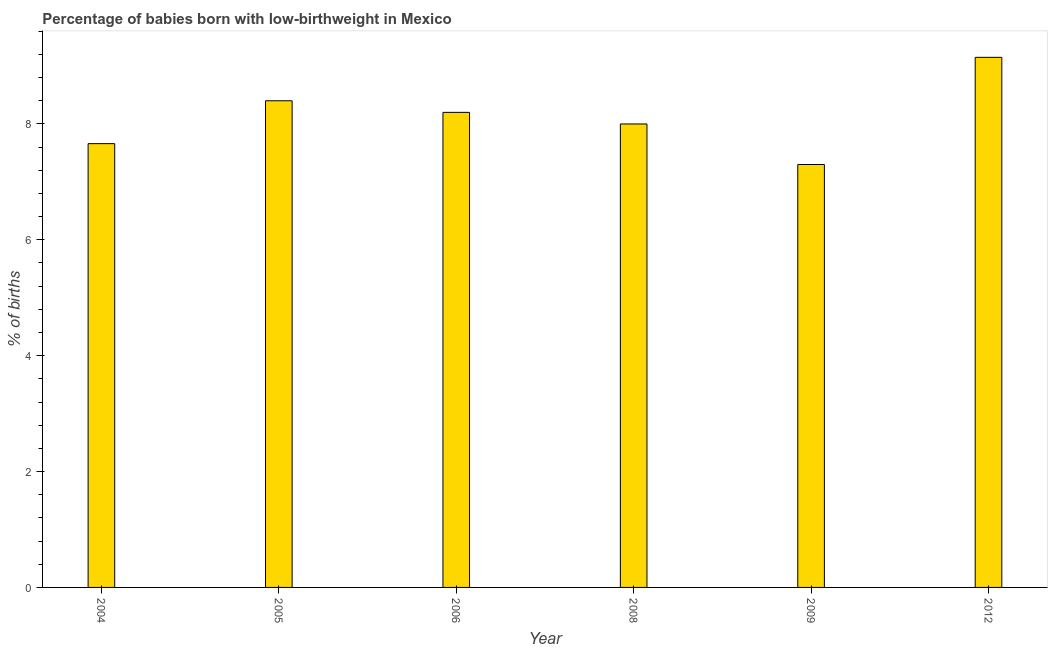Does the graph contain grids?
Provide a succinct answer. No. What is the title of the graph?
Provide a succinct answer. Percentage of babies born with low-birthweight in Mexico. What is the label or title of the Y-axis?
Your response must be concise. % of births. Across all years, what is the maximum percentage of babies who were born with low-birthweight?
Ensure brevity in your answer.  9.15. In which year was the percentage of babies who were born with low-birthweight maximum?
Offer a terse response. 2012. In which year was the percentage of babies who were born with low-birthweight minimum?
Your response must be concise. 2009. What is the sum of the percentage of babies who were born with low-birthweight?
Offer a terse response. 48.71. What is the average percentage of babies who were born with low-birthweight per year?
Make the answer very short. 8.12. What is the median percentage of babies who were born with low-birthweight?
Provide a short and direct response. 8.1. Do a majority of the years between 2008 and 2004 (inclusive) have percentage of babies who were born with low-birthweight greater than 4 %?
Offer a very short reply. Yes. What is the ratio of the percentage of babies who were born with low-birthweight in 2004 to that in 2009?
Offer a terse response. 1.05. Is the difference between the percentage of babies who were born with low-birthweight in 2005 and 2006 greater than the difference between any two years?
Your answer should be very brief. No. What is the difference between the highest and the lowest percentage of babies who were born with low-birthweight?
Provide a short and direct response. 1.85. In how many years, is the percentage of babies who were born with low-birthweight greater than the average percentage of babies who were born with low-birthweight taken over all years?
Give a very brief answer. 3. How many years are there in the graph?
Give a very brief answer. 6. What is the % of births of 2004?
Your answer should be very brief. 7.66. What is the % of births in 2005?
Ensure brevity in your answer.  8.4. What is the % of births of 2006?
Your answer should be very brief. 8.2. What is the % of births in 2008?
Offer a terse response. 8. What is the % of births of 2012?
Make the answer very short. 9.15. What is the difference between the % of births in 2004 and 2005?
Your response must be concise. -0.74. What is the difference between the % of births in 2004 and 2006?
Ensure brevity in your answer.  -0.54. What is the difference between the % of births in 2004 and 2008?
Give a very brief answer. -0.34. What is the difference between the % of births in 2004 and 2009?
Offer a very short reply. 0.36. What is the difference between the % of births in 2004 and 2012?
Offer a terse response. -1.49. What is the difference between the % of births in 2005 and 2006?
Provide a short and direct response. 0.2. What is the difference between the % of births in 2005 and 2008?
Your response must be concise. 0.4. What is the difference between the % of births in 2005 and 2012?
Give a very brief answer. -0.75. What is the difference between the % of births in 2006 and 2008?
Your answer should be compact. 0.2. What is the difference between the % of births in 2006 and 2009?
Make the answer very short. 0.9. What is the difference between the % of births in 2006 and 2012?
Your answer should be very brief. -0.95. What is the difference between the % of births in 2008 and 2009?
Offer a terse response. 0.7. What is the difference between the % of births in 2008 and 2012?
Make the answer very short. -1.15. What is the difference between the % of births in 2009 and 2012?
Give a very brief answer. -1.85. What is the ratio of the % of births in 2004 to that in 2005?
Your answer should be very brief. 0.91. What is the ratio of the % of births in 2004 to that in 2006?
Your answer should be very brief. 0.93. What is the ratio of the % of births in 2004 to that in 2008?
Ensure brevity in your answer.  0.96. What is the ratio of the % of births in 2004 to that in 2009?
Your answer should be very brief. 1.05. What is the ratio of the % of births in 2004 to that in 2012?
Keep it short and to the point. 0.84. What is the ratio of the % of births in 2005 to that in 2006?
Ensure brevity in your answer.  1.02. What is the ratio of the % of births in 2005 to that in 2008?
Offer a very short reply. 1.05. What is the ratio of the % of births in 2005 to that in 2009?
Make the answer very short. 1.15. What is the ratio of the % of births in 2005 to that in 2012?
Give a very brief answer. 0.92. What is the ratio of the % of births in 2006 to that in 2009?
Give a very brief answer. 1.12. What is the ratio of the % of births in 2006 to that in 2012?
Your answer should be very brief. 0.9. What is the ratio of the % of births in 2008 to that in 2009?
Provide a short and direct response. 1.1. What is the ratio of the % of births in 2008 to that in 2012?
Ensure brevity in your answer.  0.87. What is the ratio of the % of births in 2009 to that in 2012?
Provide a succinct answer. 0.8. 